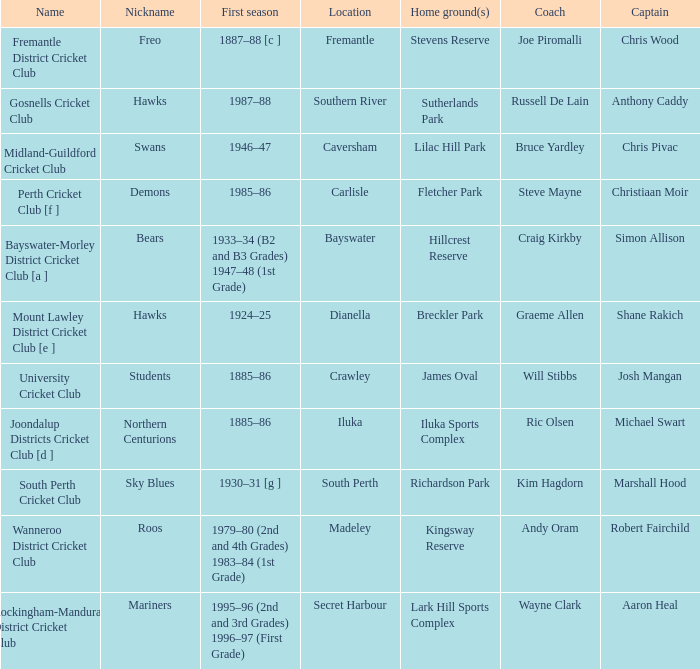What is the dates where Hillcrest Reserve is the home grounds? 1933–34 (B2 and B3 Grades) 1947–48 (1st Grade). 